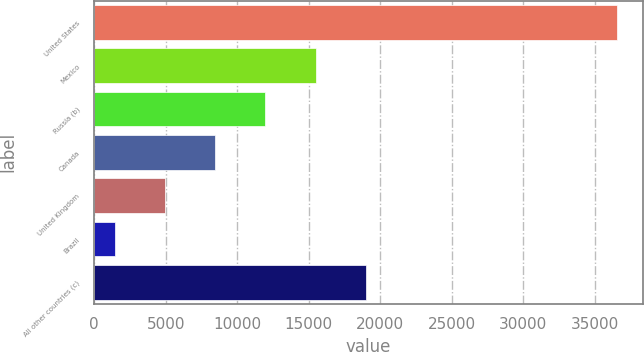Convert chart to OTSL. <chart><loc_0><loc_0><loc_500><loc_500><bar_chart><fcel>United States<fcel>Mexico<fcel>Russia (b)<fcel>Canada<fcel>United Kingdom<fcel>Brazil<fcel>All other countries (c)<nl><fcel>36546<fcel>15474.6<fcel>11962.7<fcel>8450.8<fcel>4938.9<fcel>1427<fcel>18986.5<nl></chart> 